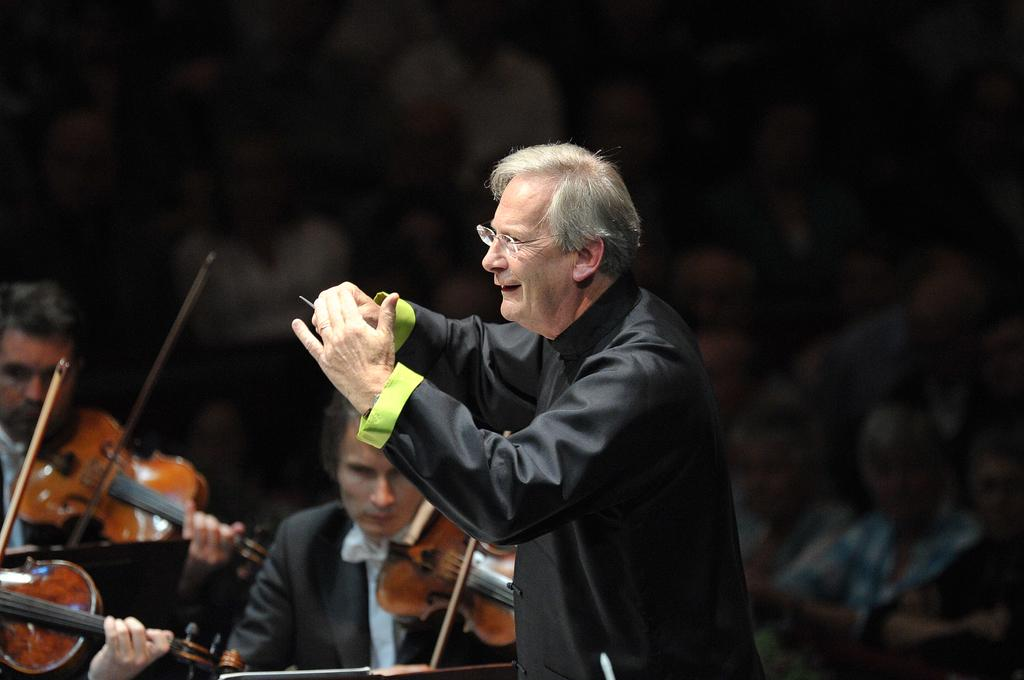What is the main subject of the image? The main subject of the image is a man. Can you describe the man's appearance? The man is wearing spectacles and a coat. What is the man doing in the image? The man is doing a sign or gesture. What can be seen happening in the background of the image? There are people playing violin, and a group of people are watching the performance. What type of stocking is the man wearing on his left leg in the image? There is no mention of stockings in the image, so we cannot determine if the man is wearing any. How does the man pull the violin string in the image? The man is not playing the violin in the image; he is doing a sign or gesture. 